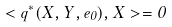<formula> <loc_0><loc_0><loc_500><loc_500>< { q } ^ { * } ( X , Y , e _ { 0 } ) , X > = 0</formula> 